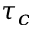Convert formula to latex. <formula><loc_0><loc_0><loc_500><loc_500>\tau _ { c }</formula> 